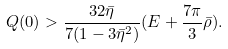<formula> <loc_0><loc_0><loc_500><loc_500>Q ( 0 ) > \frac { 3 2 \bar { \eta } } { 7 ( 1 - 3 \bar { \eta } ^ { 2 } ) } ( E + \frac { 7 \pi } { 3 } \bar { \rho } ) .</formula> 